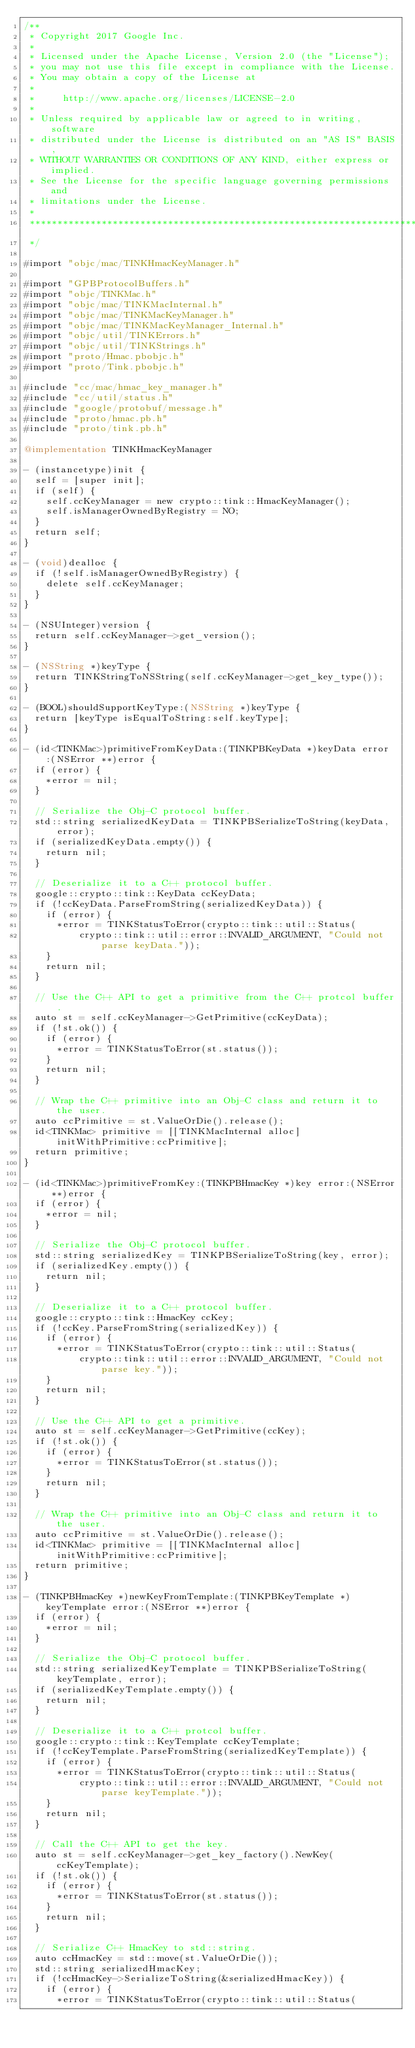Convert code to text. <code><loc_0><loc_0><loc_500><loc_500><_ObjectiveC_>/**
 * Copyright 2017 Google Inc.
 *
 * Licensed under the Apache License, Version 2.0 (the "License");
 * you may not use this file except in compliance with the License.
 * You may obtain a copy of the License at
 *
 *     http://www.apache.org/licenses/LICENSE-2.0
 *
 * Unless required by applicable law or agreed to in writing, software
 * distributed under the License is distributed on an "AS IS" BASIS,
 * WITHOUT WARRANTIES OR CONDITIONS OF ANY KIND, either express or implied.
 * See the License for the specific language governing permissions and
 * limitations under the License.
 *
 **************************************************************************
 */

#import "objc/mac/TINKHmacKeyManager.h"

#import "GPBProtocolBuffers.h"
#import "objc/TINKMac.h"
#import "objc/mac/TINKMacInternal.h"
#import "objc/mac/TINKMacKeyManager.h"
#import "objc/mac/TINKMacKeyManager_Internal.h"
#import "objc/util/TINKErrors.h"
#import "objc/util/TINKStrings.h"
#import "proto/Hmac.pbobjc.h"
#import "proto/Tink.pbobjc.h"

#include "cc/mac/hmac_key_manager.h"
#include "cc/util/status.h"
#include "google/protobuf/message.h"
#include "proto/hmac.pb.h"
#include "proto/tink.pb.h"

@implementation TINKHmacKeyManager

- (instancetype)init {
  self = [super init];
  if (self) {
    self.ccKeyManager = new crypto::tink::HmacKeyManager();
    self.isManagerOwnedByRegistry = NO;
  }
  return self;
}

- (void)dealloc {
  if (!self.isManagerOwnedByRegistry) {
    delete self.ccKeyManager;
  }
}

- (NSUInteger)version {
  return self.ccKeyManager->get_version();
}

- (NSString *)keyType {
  return TINKStringToNSString(self.ccKeyManager->get_key_type());
}

- (BOOL)shouldSupportKeyType:(NSString *)keyType {
  return [keyType isEqualToString:self.keyType];
}

- (id<TINKMac>)primitiveFromKeyData:(TINKPBKeyData *)keyData error:(NSError **)error {
  if (error) {
    *error = nil;
  }

  // Serialize the Obj-C protocol buffer.
  std::string serializedKeyData = TINKPBSerializeToString(keyData, error);
  if (serializedKeyData.empty()) {
    return nil;
  }

  // Deserialize it to a C++ protocol buffer.
  google::crypto::tink::KeyData ccKeyData;
  if (!ccKeyData.ParseFromString(serializedKeyData)) {
    if (error) {
      *error = TINKStatusToError(crypto::tink::util::Status(
          crypto::tink::util::error::INVALID_ARGUMENT, "Could not parse keyData."));
    }
    return nil;
  }

  // Use the C++ API to get a primitive from the C++ protcol buffer.
  auto st = self.ccKeyManager->GetPrimitive(ccKeyData);
  if (!st.ok()) {
    if (error) {
      *error = TINKStatusToError(st.status());
    }
    return nil;
  }

  // Wrap the C++ primitive into an Obj-C class and return it to the user.
  auto ccPrimitive = st.ValueOrDie().release();
  id<TINKMac> primitive = [[TINKMacInternal alloc] initWithPrimitive:ccPrimitive];
  return primitive;
}

- (id<TINKMac>)primitiveFromKey:(TINKPBHmacKey *)key error:(NSError **)error {
  if (error) {
    *error = nil;
  }

  // Serialize the Obj-C protocol buffer.
  std::string serializedKey = TINKPBSerializeToString(key, error);
  if (serializedKey.empty()) {
    return nil;
  }

  // Deserialize it to a C++ protocol buffer.
  google::crypto::tink::HmacKey ccKey;
  if (!ccKey.ParseFromString(serializedKey)) {
    if (error) {
      *error = TINKStatusToError(crypto::tink::util::Status(
          crypto::tink::util::error::INVALID_ARGUMENT, "Could not parse key."));
    }
    return nil;
  }

  // Use the C++ API to get a primitive.
  auto st = self.ccKeyManager->GetPrimitive(ccKey);
  if (!st.ok()) {
    if (error) {
      *error = TINKStatusToError(st.status());
    }
    return nil;
  }

  // Wrap the C++ primitive into an Obj-C class and return it to the user.
  auto ccPrimitive = st.ValueOrDie().release();
  id<TINKMac> primitive = [[TINKMacInternal alloc] initWithPrimitive:ccPrimitive];
  return primitive;
}

- (TINKPBHmacKey *)newKeyFromTemplate:(TINKPBKeyTemplate *)keyTemplate error:(NSError **)error {
  if (error) {
    *error = nil;
  }

  // Serialize the Obj-C protocol buffer.
  std::string serializedKeyTemplate = TINKPBSerializeToString(keyTemplate, error);
  if (serializedKeyTemplate.empty()) {
    return nil;
  }

  // Deserialize it to a C++ protcol buffer.
  google::crypto::tink::KeyTemplate ccKeyTemplate;
  if (!ccKeyTemplate.ParseFromString(serializedKeyTemplate)) {
    if (error) {
      *error = TINKStatusToError(crypto::tink::util::Status(
          crypto::tink::util::error::INVALID_ARGUMENT, "Could not parse keyTemplate."));
    }
    return nil;
  }

  // Call the C++ API to get the key.
  auto st = self.ccKeyManager->get_key_factory().NewKey(ccKeyTemplate);
  if (!st.ok()) {
    if (error) {
      *error = TINKStatusToError(st.status());
    }
    return nil;
  }

  // Serialize C++ HmacKey to std::string.
  auto ccHmacKey = std::move(st.ValueOrDie());
  std::string serializedHmacKey;
  if (!ccHmacKey->SerializeToString(&serializedHmacKey)) {
    if (error) {
      *error = TINKStatusToError(crypto::tink::util::Status(</code> 